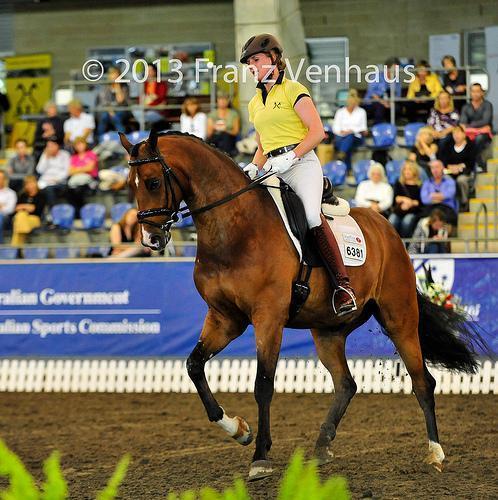How many horses are there?
Give a very brief answer. 1. 